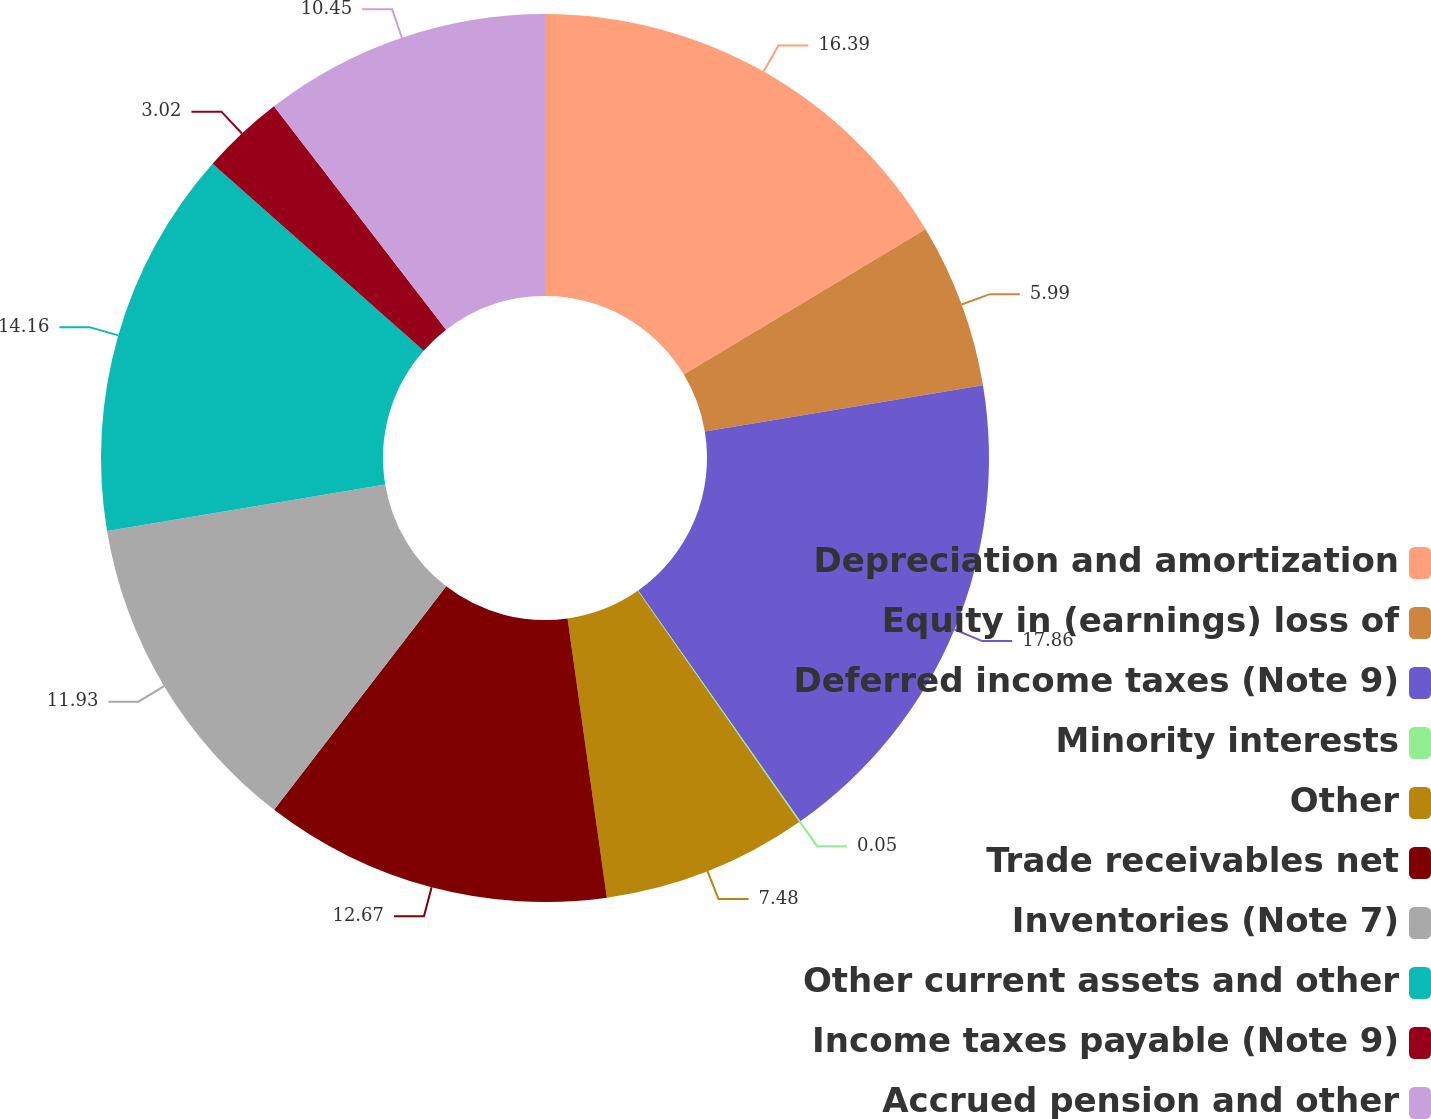<chart> <loc_0><loc_0><loc_500><loc_500><pie_chart><fcel>Depreciation and amortization<fcel>Equity in (earnings) loss of<fcel>Deferred income taxes (Note 9)<fcel>Minority interests<fcel>Other<fcel>Trade receivables net<fcel>Inventories (Note 7)<fcel>Other current assets and other<fcel>Income taxes payable (Note 9)<fcel>Accrued pension and other<nl><fcel>16.39%<fcel>5.99%<fcel>17.87%<fcel>0.05%<fcel>7.48%<fcel>12.67%<fcel>11.93%<fcel>14.16%<fcel>3.02%<fcel>10.45%<nl></chart> 